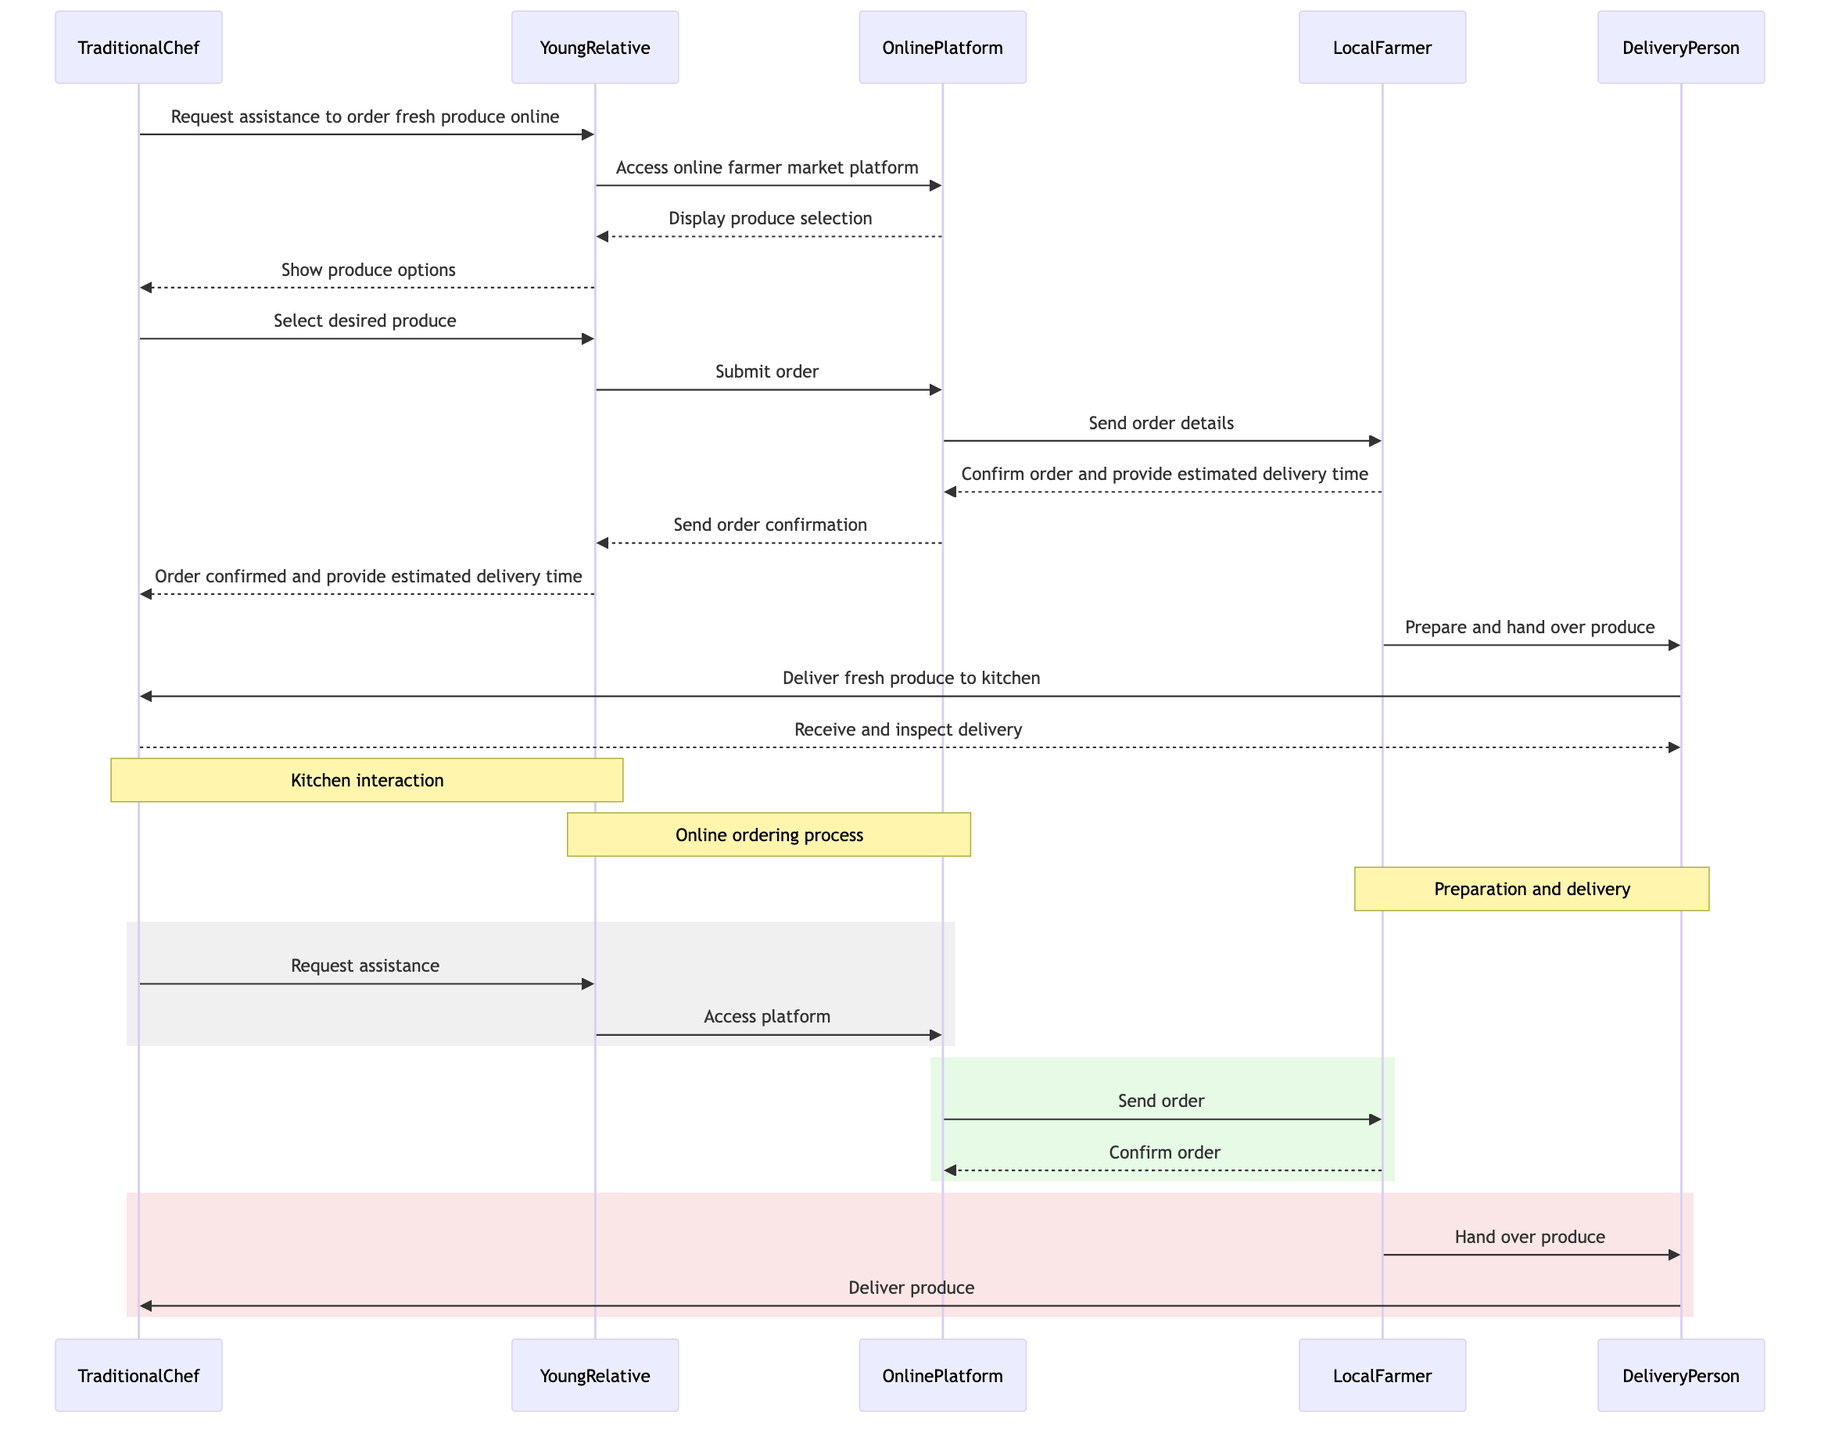What is the first action taken in the sequence? The first action is the TraditionalChef requesting assistance to order fresh produce online. This is the first message that appears in the sequence flow.
Answer: Request assistance to order fresh produce online How many participants are involved in the diagram? The number of participants can be counted directly from the list of actors in the diagram. There are five actors: TraditionalChef, YoungRelative, OnlinePlatform, LocalFarmer, and DeliveryPerson.
Answer: Five Who confirms the order back to the YoungRelative? The confirmation of the order is provided by the LocalFarmer, who sends back the order confirmation and estimated delivery time back to the OnlinePlatform, which then sends it to the YoungRelative.
Answer: LocalFarmer What happens after the YoungRelative submits the order? After the YoungRelative submits the order, the OnlinePlatform sends the order details to the LocalFarmer, allowing them to process the order. This step is the immediate follow-up in the sequence.
Answer: Send order details Which two participants are involved during the preparation of the produce? The LocalFarmer and DeliveryPerson are directly involved during the preparation of the produce. The LocalFarmer prepares and hands over the produce to the DeliveryPerson.
Answer: LocalFarmer and DeliveryPerson What does the TraditionalChef do upon receiving the delivery? Upon receiving the delivery, the TraditionalChef inspects the delivery to ensure it meets the expected quality and specifications. This is the final action by the TraditionalChef in the sequence.
Answer: Receive and inspect delivery How many messages are exchanged between the YoungRelative and the OnlinePlatform? The messages exchanged between YoungRelative and OnlinePlatform can be traced throughout the sequence. From the sequence, there are three messages exchanged: accessing the platform, submitting the order, and receiving confirmation.
Answer: Three What action follows after the LocalFarmer prepares the produce? After the LocalFarmer prepares the produce, the action that follows is that the DeliveryPerson is sent to deliver the fresh produce to the TraditionalChef's kitchen. This is a direct continuation in the sequence flow.
Answer: Deliver fresh produce to kitchen What type of document is sent to the YoungRelative as the order confirmation? The order confirmation that is sent to the YoungRelative is specified as an "OrderConfirmation," which identifies the document type of the confirmation received.
Answer: Document 